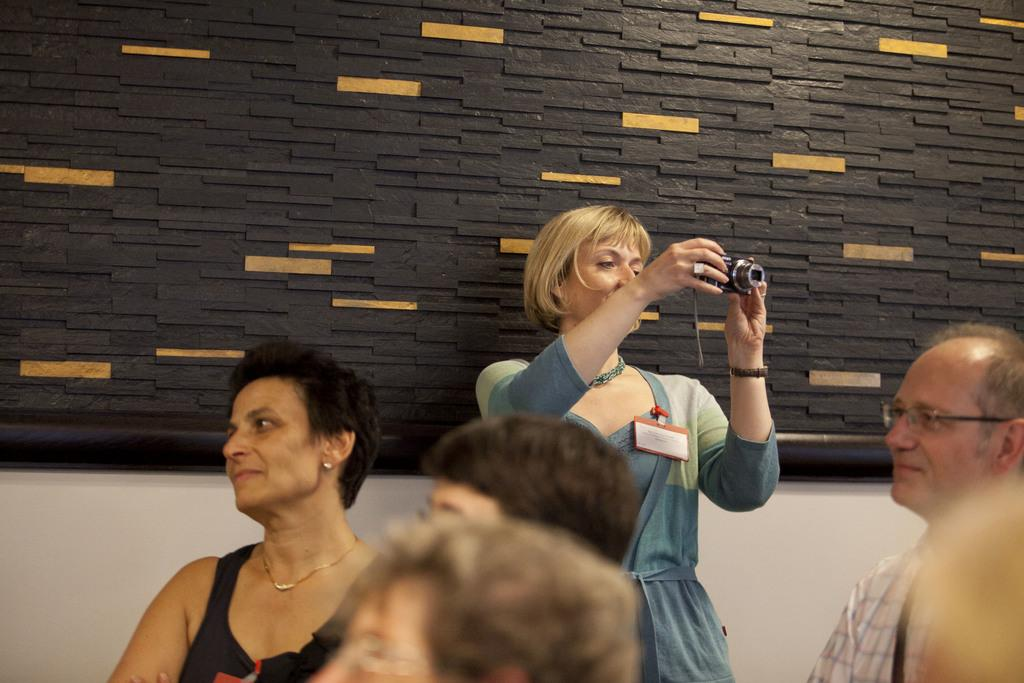What are the people in the image wearing? The people in the image are wearing clothes. Can you describe any accessories worn by the woman in the image? The woman is wearing a neck chain and ear stud. What is the woman holding in her hand? The woman is holding a camera in her hand. What can be seen in the background of the image? There is a wall in the image. What type of hammer is the woman using to tell a joke in the image? There is no hammer or joke present in the image; the woman is holding a camera. Is there a mask visible on any of the people in the image? No, there are no masks visible on any of the people in the image. 